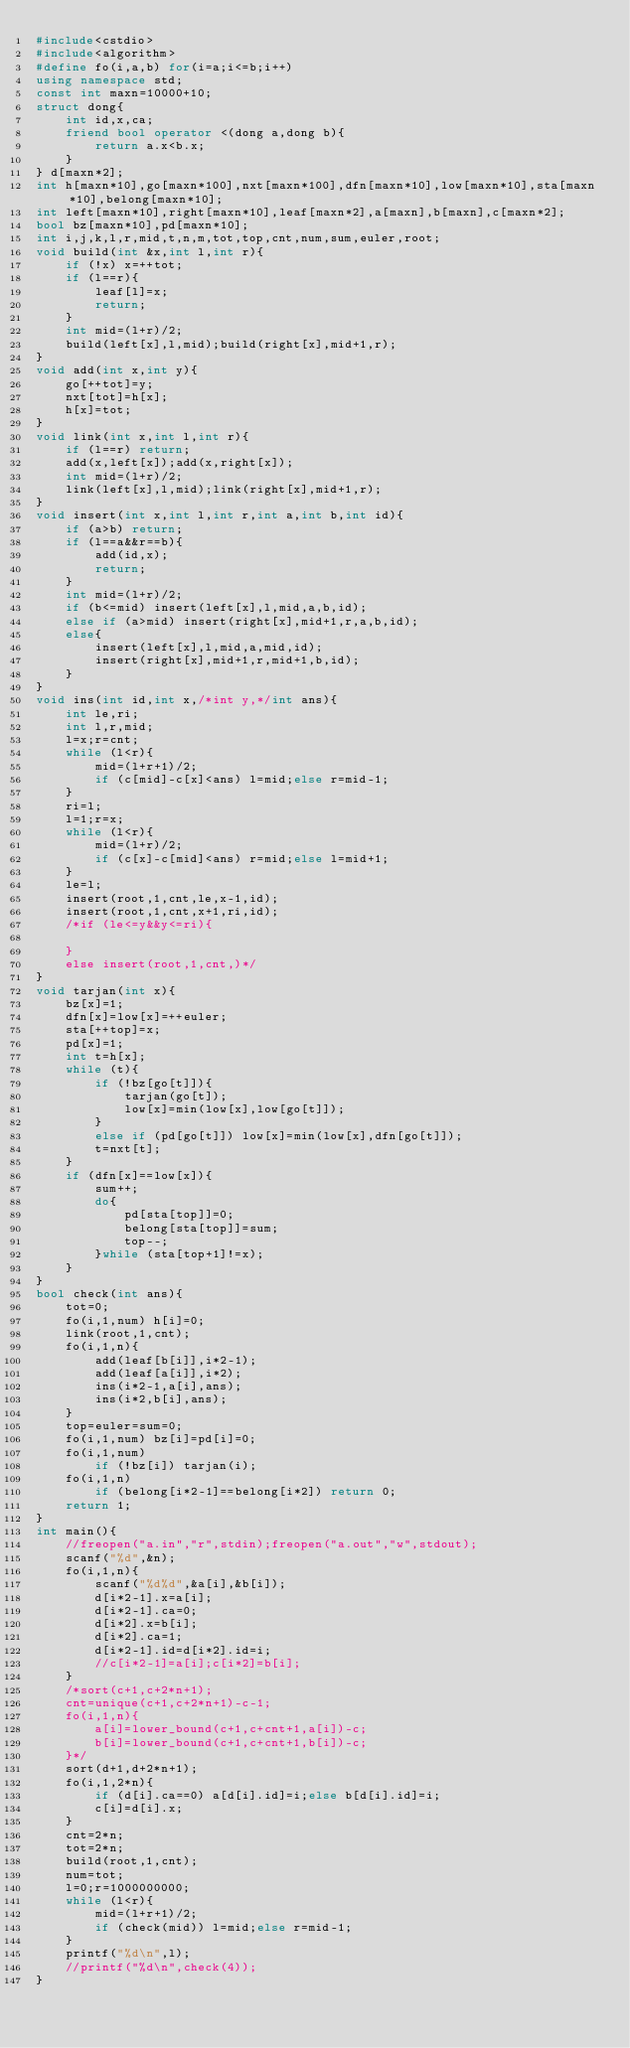Convert code to text. <code><loc_0><loc_0><loc_500><loc_500><_C++_>#include<cstdio>
#include<algorithm>
#define fo(i,a,b) for(i=a;i<=b;i++)
using namespace std;
const int maxn=10000+10;
struct dong{
	int id,x,ca;
	friend bool operator <(dong a,dong b){
		return a.x<b.x;
	}
} d[maxn*2];
int h[maxn*10],go[maxn*100],nxt[maxn*100],dfn[maxn*10],low[maxn*10],sta[maxn*10],belong[maxn*10];
int left[maxn*10],right[maxn*10],leaf[maxn*2],a[maxn],b[maxn],c[maxn*2];
bool bz[maxn*10],pd[maxn*10];
int i,j,k,l,r,mid,t,n,m,tot,top,cnt,num,sum,euler,root;
void build(int &x,int l,int r){
	if (!x) x=++tot;
	if (l==r){
		leaf[l]=x;
		return;
	}
	int mid=(l+r)/2;
	build(left[x],l,mid);build(right[x],mid+1,r);
}
void add(int x,int y){
	go[++tot]=y;
	nxt[tot]=h[x];
	h[x]=tot;
}
void link(int x,int l,int r){
	if (l==r) return;
	add(x,left[x]);add(x,right[x]);
	int mid=(l+r)/2;
	link(left[x],l,mid);link(right[x],mid+1,r);
}
void insert(int x,int l,int r,int a,int b,int id){
	if (a>b) return;
	if (l==a&&r==b){
		add(id,x);
		return;
	}
	int mid=(l+r)/2;
	if (b<=mid) insert(left[x],l,mid,a,b,id);
	else if (a>mid) insert(right[x],mid+1,r,a,b,id);
	else{
		insert(left[x],l,mid,a,mid,id);
		insert(right[x],mid+1,r,mid+1,b,id);
	}
}
void ins(int id,int x,/*int y,*/int ans){
	int le,ri;
	int l,r,mid;
	l=x;r=cnt;
	while (l<r){
		mid=(l+r+1)/2;
		if (c[mid]-c[x]<ans) l=mid;else r=mid-1;
	}
	ri=l;
	l=1;r=x;
	while (l<r){
		mid=(l+r)/2;
		if (c[x]-c[mid]<ans) r=mid;else l=mid+1;
	}
	le=l;
	insert(root,1,cnt,le,x-1,id);
	insert(root,1,cnt,x+1,ri,id);
	/*if (le<=y&&y<=ri){
		
	}
	else insert(root,1,cnt,)*/
}
void tarjan(int x){
	bz[x]=1;
	dfn[x]=low[x]=++euler;
	sta[++top]=x;
	pd[x]=1;
	int t=h[x];
	while (t){
		if (!bz[go[t]]){
			tarjan(go[t]);
			low[x]=min(low[x],low[go[t]]);
		}
		else if (pd[go[t]]) low[x]=min(low[x],dfn[go[t]]);
		t=nxt[t];
	}
	if (dfn[x]==low[x]){
		sum++;
		do{
			pd[sta[top]]=0;
			belong[sta[top]]=sum;
			top--;
		}while (sta[top+1]!=x);
	}
}
bool check(int ans){
	tot=0;
	fo(i,1,num) h[i]=0;
	link(root,1,cnt);
	fo(i,1,n){
		add(leaf[b[i]],i*2-1);
		add(leaf[a[i]],i*2);
		ins(i*2-1,a[i],ans);
		ins(i*2,b[i],ans);
	}
	top=euler=sum=0;
	fo(i,1,num) bz[i]=pd[i]=0;
	fo(i,1,num)
		if (!bz[i]) tarjan(i);
	fo(i,1,n)
		if (belong[i*2-1]==belong[i*2]) return 0;
	return 1;
}
int main(){
	//freopen("a.in","r",stdin);freopen("a.out","w",stdout);
	scanf("%d",&n);
	fo(i,1,n){
		scanf("%d%d",&a[i],&b[i]);
		d[i*2-1].x=a[i];
		d[i*2-1].ca=0;
		d[i*2].x=b[i];
		d[i*2].ca=1;
		d[i*2-1].id=d[i*2].id=i;
		//c[i*2-1]=a[i];c[i*2]=b[i];
	}
	/*sort(c+1,c+2*n+1);
	cnt=unique(c+1,c+2*n+1)-c-1;
	fo(i,1,n){
		a[i]=lower_bound(c+1,c+cnt+1,a[i])-c;
		b[i]=lower_bound(c+1,c+cnt+1,b[i])-c;
	}*/
	sort(d+1,d+2*n+1);
	fo(i,1,2*n){
		if (d[i].ca==0) a[d[i].id]=i;else b[d[i].id]=i;
		c[i]=d[i].x;
	}
	cnt=2*n;
	tot=2*n;
	build(root,1,cnt);
	num=tot;
	l=0;r=1000000000;
	while (l<r){
		mid=(l+r+1)/2;
		if (check(mid)) l=mid;else r=mid-1;
	}
	printf("%d\n",l);
	//printf("%d\n",check(4));
}</code> 